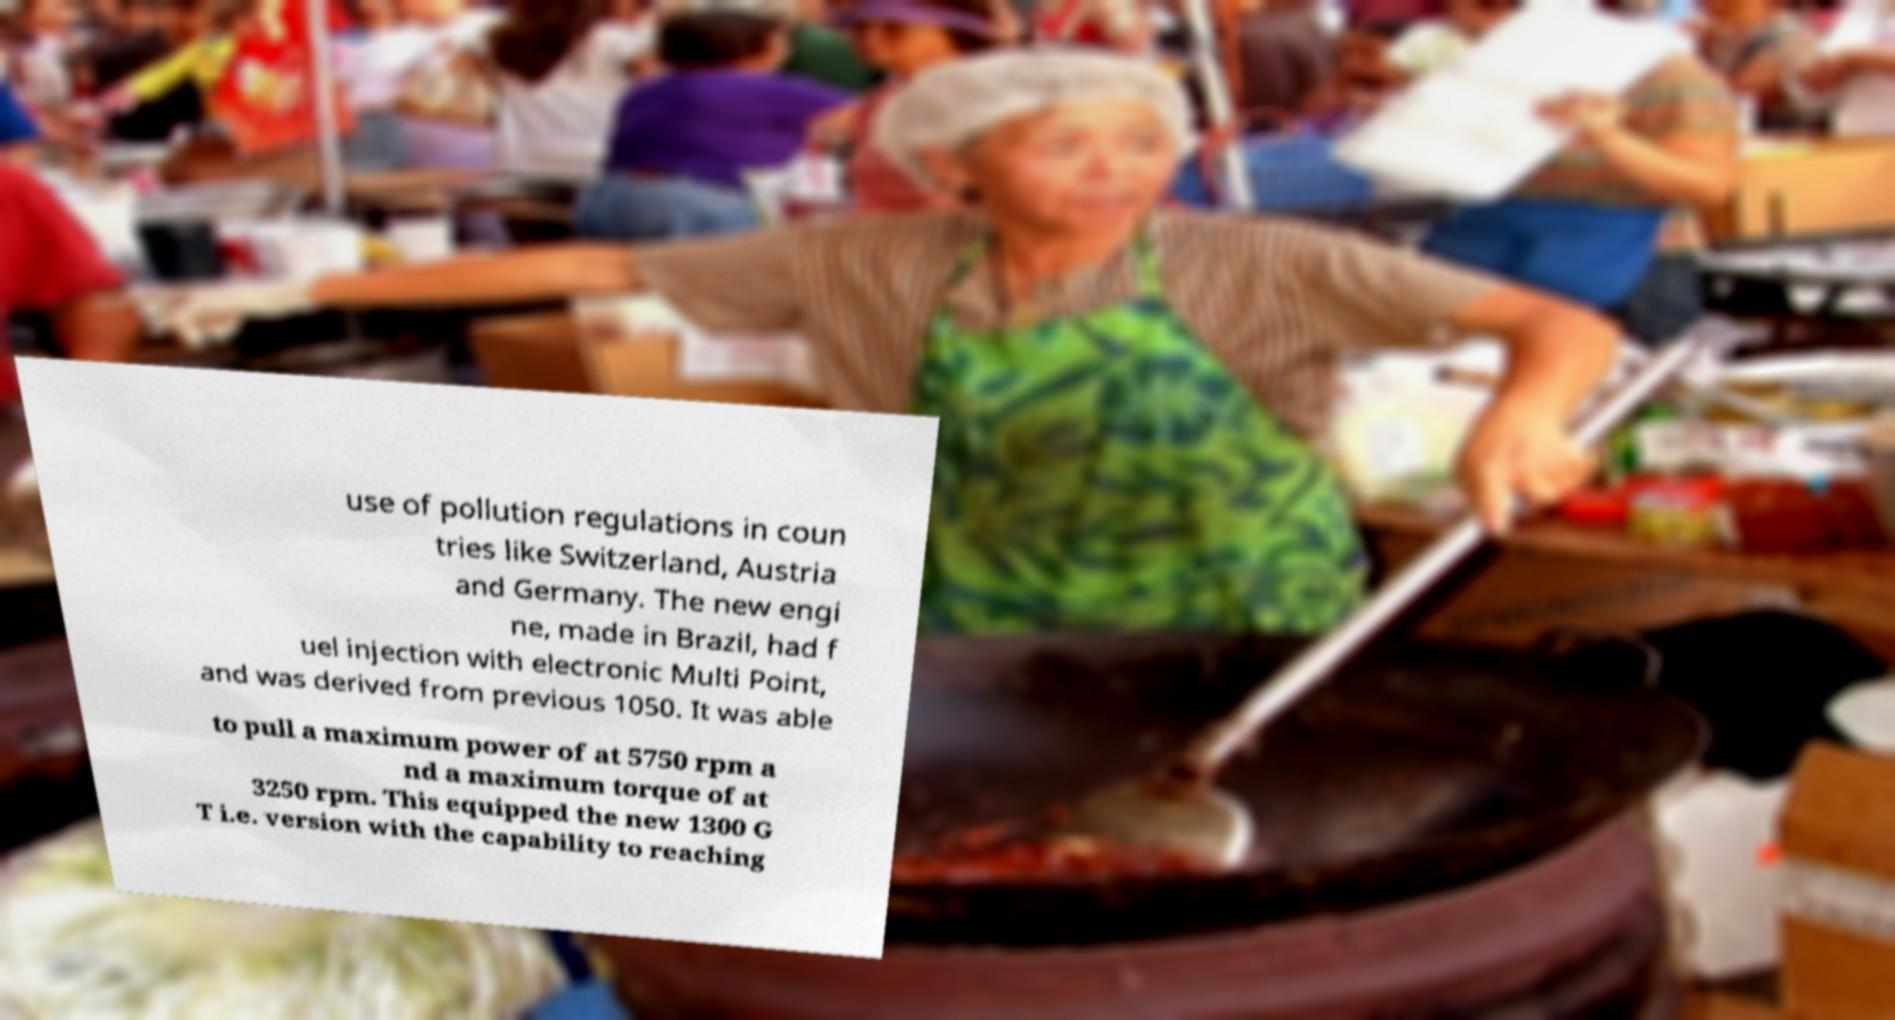Can you read and provide the text displayed in the image?This photo seems to have some interesting text. Can you extract and type it out for me? use of pollution regulations in coun tries like Switzerland, Austria and Germany. The new engi ne, made in Brazil, had f uel injection with electronic Multi Point, and was derived from previous 1050. It was able to pull a maximum power of at 5750 rpm a nd a maximum torque of at 3250 rpm. This equipped the new 1300 G T i.e. version with the capability to reaching 